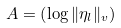Convert formula to latex. <formula><loc_0><loc_0><loc_500><loc_500>A = \left ( \log \| \eta _ { l } \| _ { v } \right )</formula> 